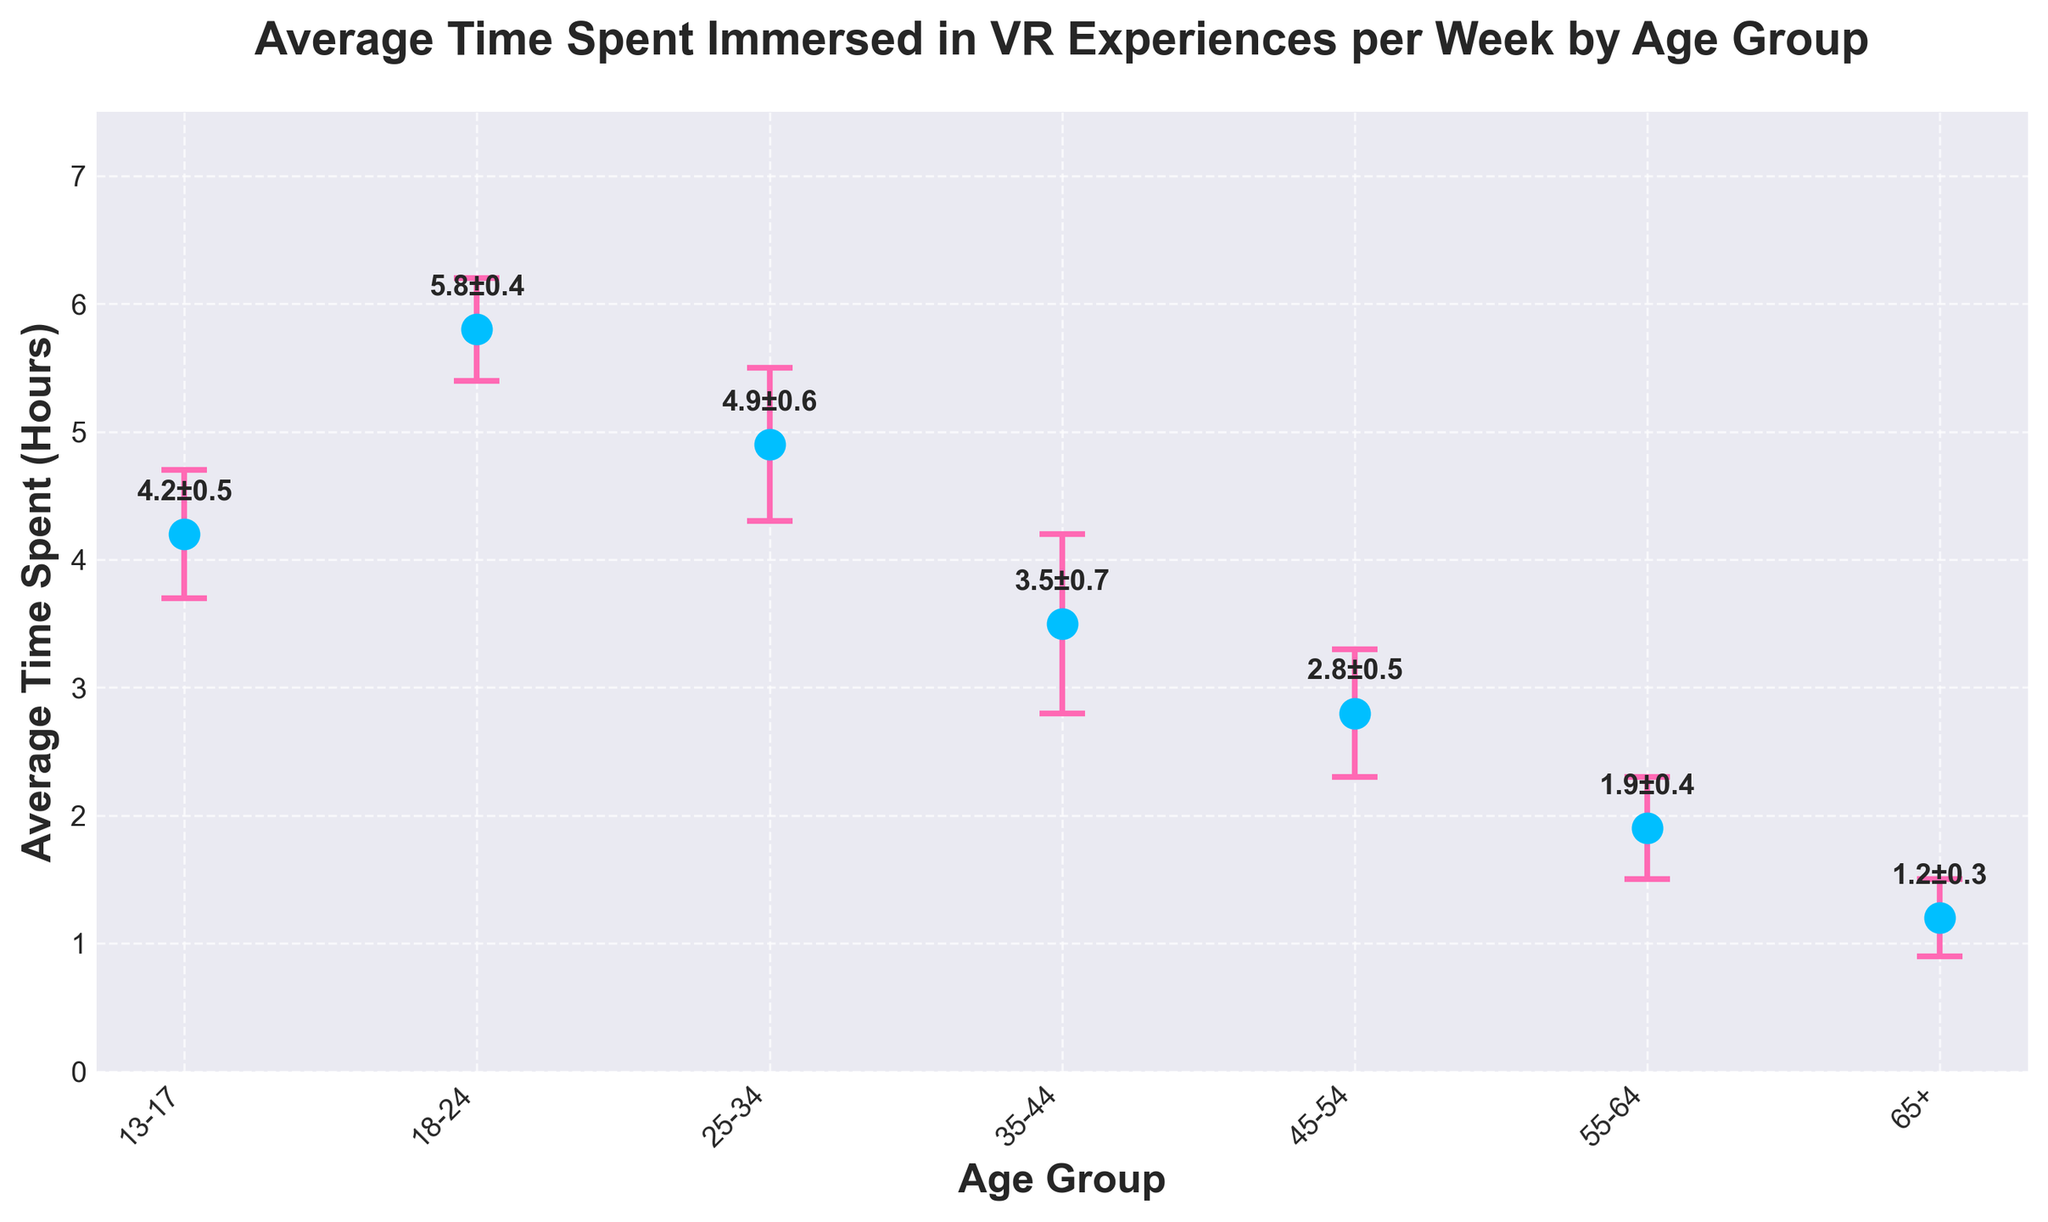What is the title of the plot? The title is displayed at the top of the plot. It reads, "Average Time Spent Immersed in VR Experiences per Week by Age Group".
Answer: Average Time Spent Immersed in VR Experiences per Week by Age Group Which age group spends the highest average time immersed in VR experiences per week? By observing the dot plot, the group with the highest average time spent is the one with the highest dot. This is the 18-24 age group, which spends an average of 5.8 hours per week.
Answer: 18-24 What is the average time spent immersed in VR experiences per week by the 35-44 age group? You can find the value by looking at the vertical position of the dot corresponding to the 35-44 age group. The dot is at 3.5 hours.
Answer: 3.5 hours What is the difference in average time spent immersed in VR experiences per week between the 25-34 and 55-64 age groups? The average time for the 25-34 age group is 4.9 hours and for the 55-64 age group is 1.9 hours. Subtracting these values gives 4.9 - 1.9 = 3.0 hours.
Answer: 3.0 hours Which age group has the largest standard error, and what is that error? The size of the error bars indicates the standard error. The 35-44 age group has the largest error bar with a standard error of 0.7.
Answer: 35-44, 0.7 How does the average time spent by the group aged 13-17 compare with the group aged 45-54? By comparing the dots' positions for the two age groups, the 13-17 group spends an average of 4.2 hours, while the 45-54 group spends 2.8 hours. The 13-17 group spends more time.
Answer: 13-17 spends more time What is the overall trend in average time spent in VR across the age groups? By observing the plot from left to right, it is evident that the average time spent in VR generally decreases as age increases, with a peak at the 18-24 age group.
Answer: Decreases with age What is the sum of average times spent by the 18-24 and 25-34 age groups? The average times for the 18-24 and 25-34 age groups are 5.8 hours and 4.9 hours, respectively. The sum is 5.8 + 4.9 = 10.7 hours.
Answer: 10.7 hours Which age group has the smallest average time spent in VR, and what is that time? The age group with the smallest average time is the one with the lowest dot. The 65+ age group has the smallest average time of 1.2 hours per week.
Answer: 65+, 1.2 hours For the 45-54 age group, what range does the error bar cover? For the 45-54 age group, the average time is 2.8 hours with a standard error of 0.5. The error bar covers from 2.8 - 0.5 to 2.8 + 0.5, or from 2.3 to 3.3 hours.
Answer: 2.3 to 3.3 hours 